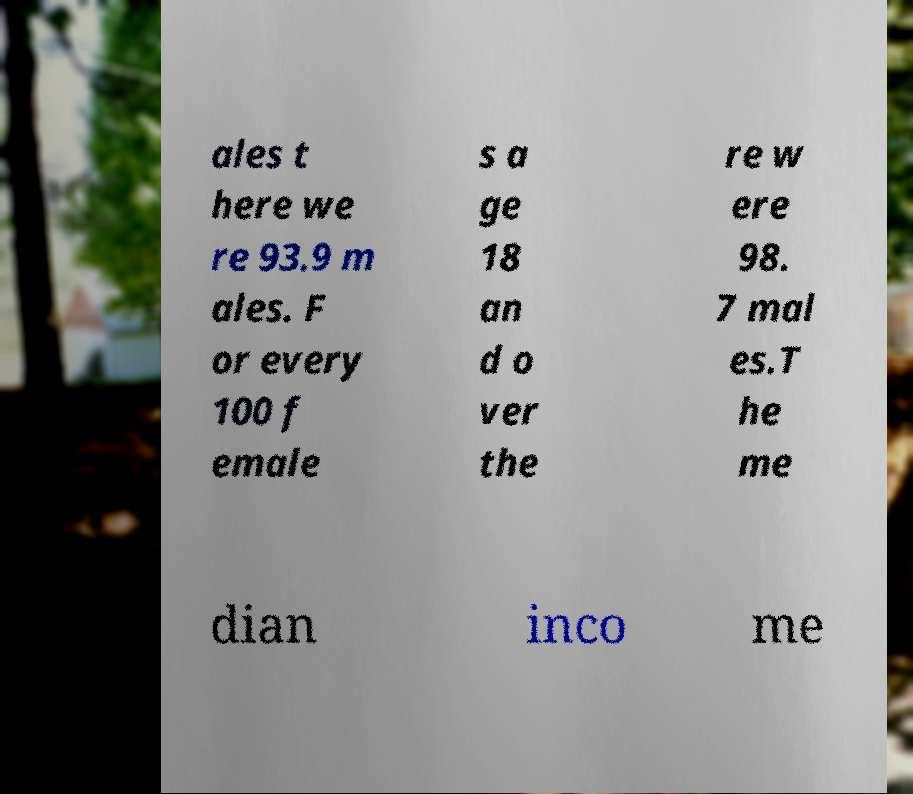Please identify and transcribe the text found in this image. ales t here we re 93.9 m ales. F or every 100 f emale s a ge 18 an d o ver the re w ere 98. 7 mal es.T he me dian inco me 